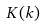Convert formula to latex. <formula><loc_0><loc_0><loc_500><loc_500>K ( k )</formula> 